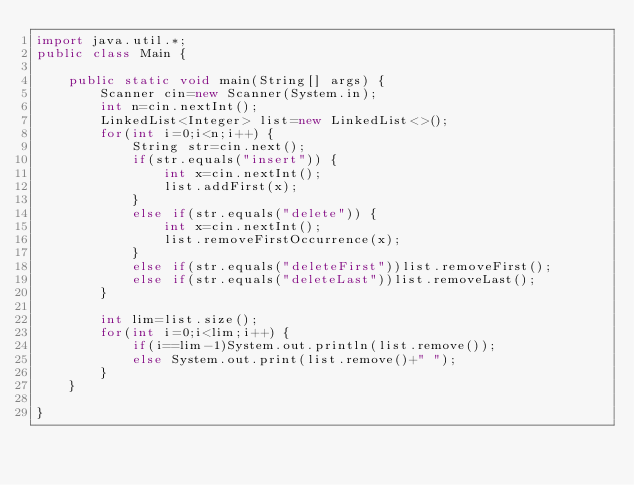Convert code to text. <code><loc_0><loc_0><loc_500><loc_500><_Java_>import java.util.*;
public class Main {

	public static void main(String[] args) {
		Scanner cin=new Scanner(System.in);
		int n=cin.nextInt();
		LinkedList<Integer> list=new LinkedList<>();
		for(int i=0;i<n;i++) {
			String str=cin.next();
			if(str.equals("insert")) {
				int x=cin.nextInt();
				list.addFirst(x);
			}
			else if(str.equals("delete")) {
				int x=cin.nextInt();
				list.removeFirstOccurrence(x);
			}
			else if(str.equals("deleteFirst"))list.removeFirst();
			else if(str.equals("deleteLast"))list.removeLast();
		}
		
		int lim=list.size();
		for(int i=0;i<lim;i++) {
			if(i==lim-1)System.out.println(list.remove());
			else System.out.print(list.remove()+" ");
		}
	}

}

</code> 